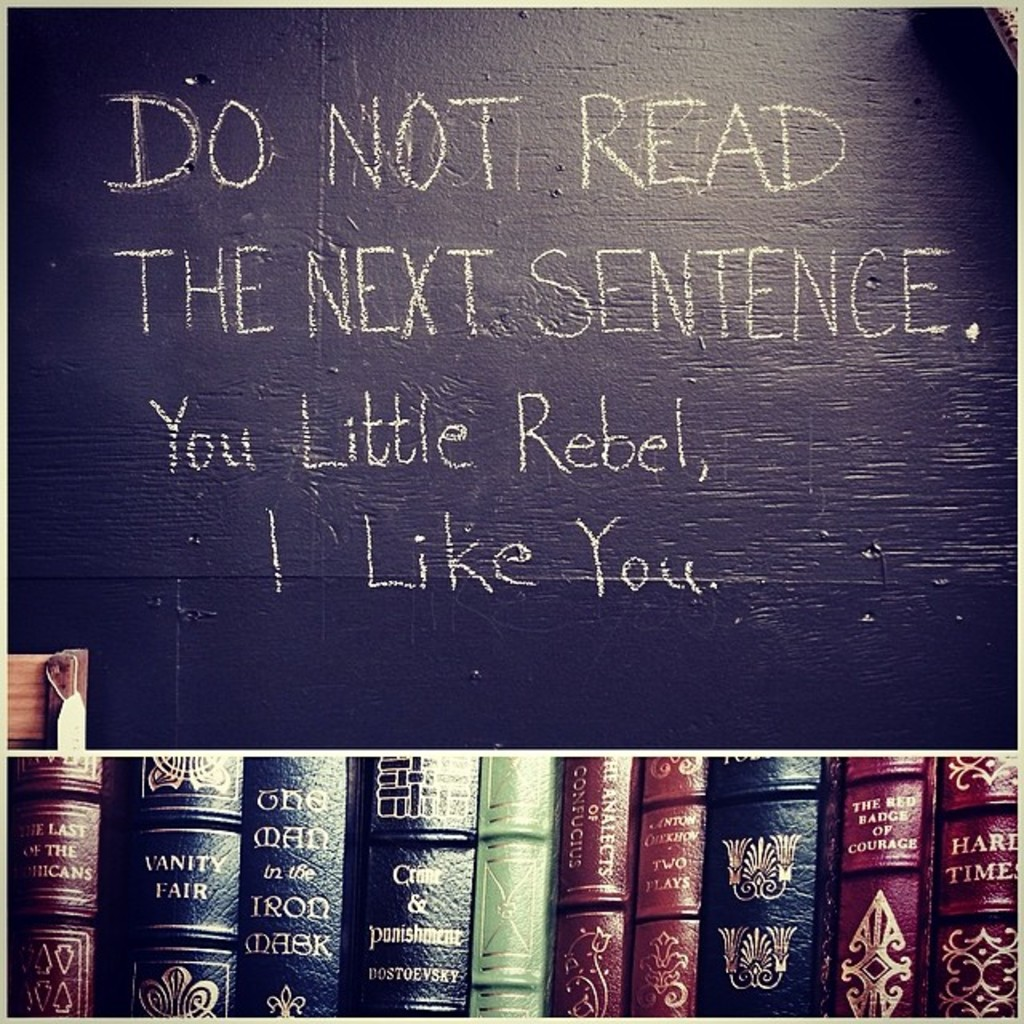What might be the purpose or function of this room based on the image? The room captured in the image likely serves a dual purpose: it is a space for leisure reading and perhaps also for informal education or study. The combination of a playful message on the blackboard with a selection of profound literary works implies a setting that blends lightheartedness with intellectual engagement. This suggests it might be part of a home library, a school, or even a cozy corner of a bookstore or cafe designed to invite visitors to explore literature in a friendly environment. 